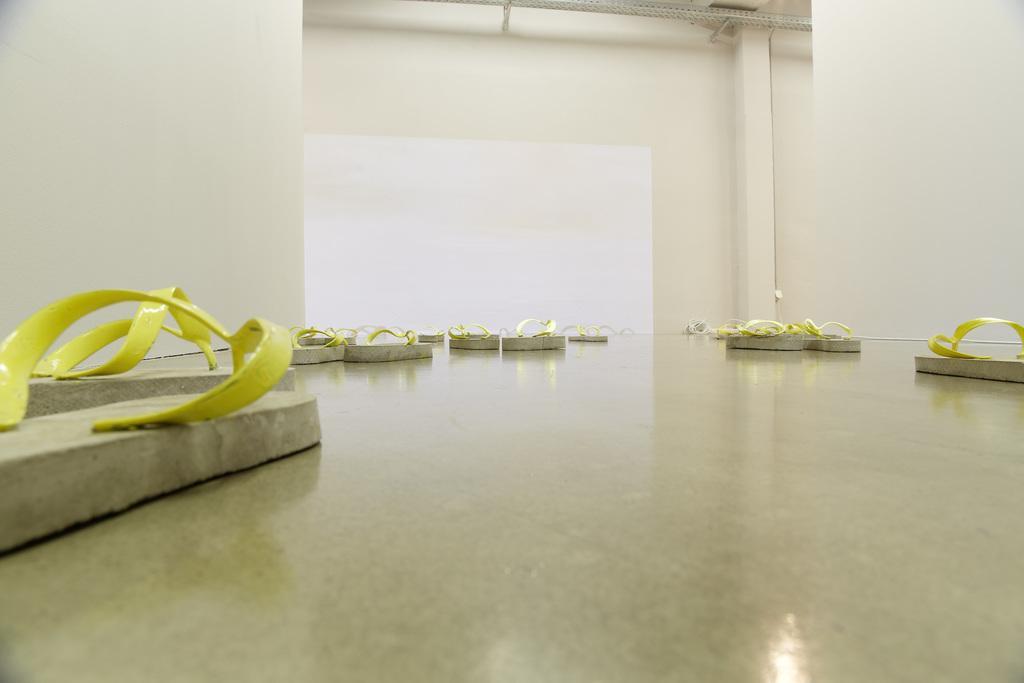How would you summarize this image in a sentence or two? In this image, we can see slippers on the floor and in the background, there is a wall and we can see some rods. 